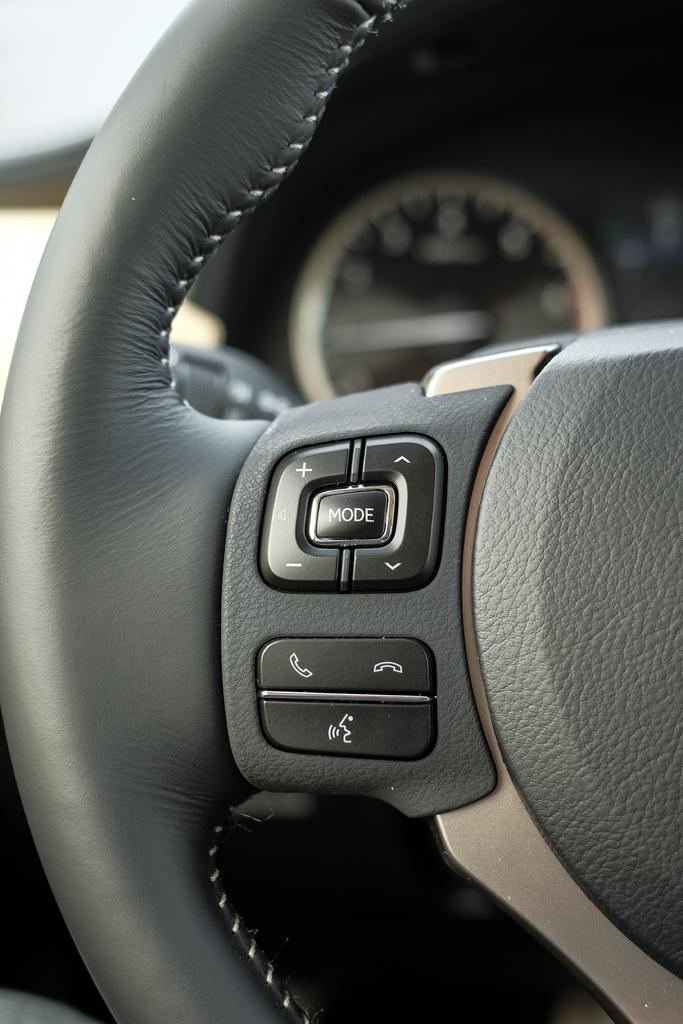What is the main object in the image? There is a steering wheel with buttons in the image. What other car-related item can be seen in the image? There is a car gauge in the image. How does the beginner feel about the surprise in the cloud in the image? There is no mention of a beginner, surprise, or cloud in the image; it only features a steering wheel with buttons and a car gauge. 